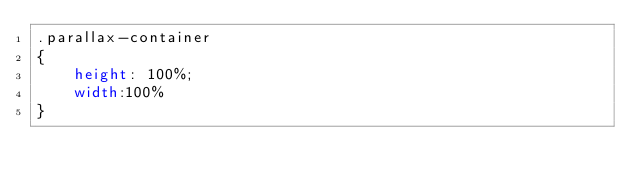Convert code to text. <code><loc_0><loc_0><loc_500><loc_500><_CSS_>.parallax-container
{
	height: 100%;
	width:100%
}</code> 